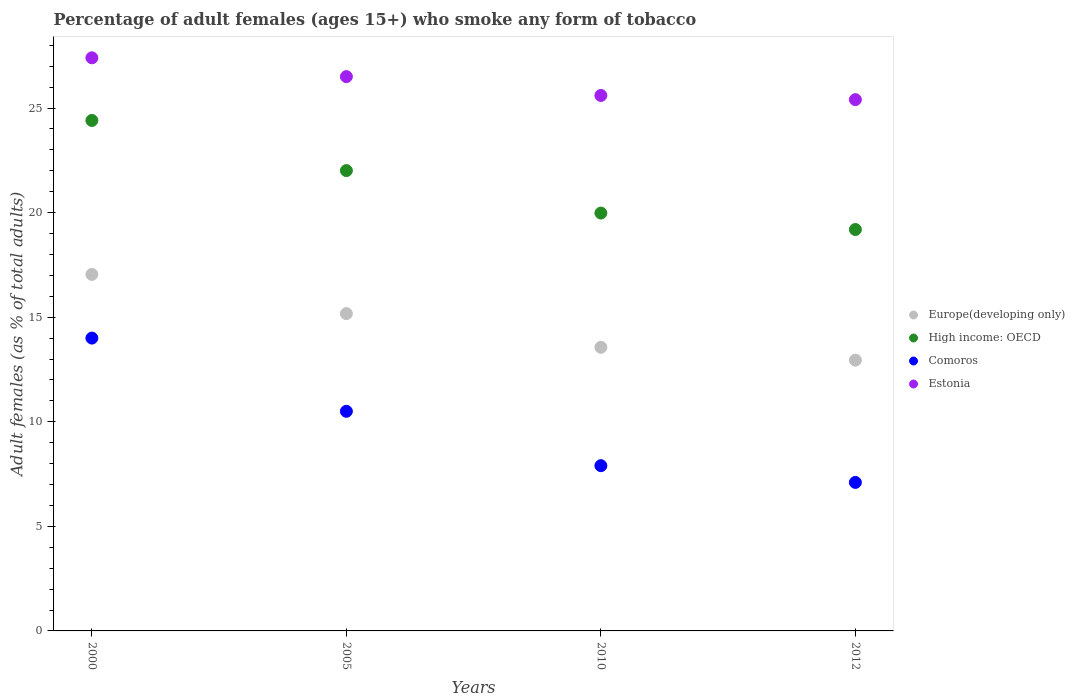Is the number of dotlines equal to the number of legend labels?
Offer a very short reply. Yes. What is the percentage of adult females who smoke in Europe(developing only) in 2000?
Give a very brief answer. 17.04. Across all years, what is the maximum percentage of adult females who smoke in Europe(developing only)?
Keep it short and to the point. 17.04. Across all years, what is the minimum percentage of adult females who smoke in Europe(developing only)?
Keep it short and to the point. 12.95. In which year was the percentage of adult females who smoke in High income: OECD minimum?
Ensure brevity in your answer.  2012. What is the total percentage of adult females who smoke in Estonia in the graph?
Keep it short and to the point. 104.9. What is the difference between the percentage of adult females who smoke in Estonia in 2005 and that in 2012?
Give a very brief answer. 1.1. What is the difference between the percentage of adult females who smoke in Europe(developing only) in 2012 and the percentage of adult females who smoke in High income: OECD in 2010?
Keep it short and to the point. -7.03. What is the average percentage of adult females who smoke in Estonia per year?
Make the answer very short. 26.23. In the year 2005, what is the difference between the percentage of adult females who smoke in High income: OECD and percentage of adult females who smoke in Comoros?
Offer a terse response. 11.51. In how many years, is the percentage of adult females who smoke in Estonia greater than 8 %?
Your response must be concise. 4. What is the ratio of the percentage of adult females who smoke in Europe(developing only) in 2000 to that in 2012?
Provide a short and direct response. 1.32. What is the difference between the highest and the second highest percentage of adult females who smoke in Comoros?
Offer a terse response. 3.5. What is the difference between the highest and the lowest percentage of adult females who smoke in Europe(developing only)?
Provide a succinct answer. 4.1. In how many years, is the percentage of adult females who smoke in High income: OECD greater than the average percentage of adult females who smoke in High income: OECD taken over all years?
Provide a short and direct response. 2. Is the sum of the percentage of adult females who smoke in Comoros in 2005 and 2012 greater than the maximum percentage of adult females who smoke in High income: OECD across all years?
Provide a short and direct response. No. Does the percentage of adult females who smoke in Estonia monotonically increase over the years?
Ensure brevity in your answer.  No. Is the percentage of adult females who smoke in Comoros strictly less than the percentage of adult females who smoke in Estonia over the years?
Make the answer very short. Yes. How many dotlines are there?
Keep it short and to the point. 4. How many years are there in the graph?
Make the answer very short. 4. What is the difference between two consecutive major ticks on the Y-axis?
Keep it short and to the point. 5. Does the graph contain grids?
Offer a very short reply. No. Where does the legend appear in the graph?
Offer a terse response. Center right. How many legend labels are there?
Ensure brevity in your answer.  4. How are the legend labels stacked?
Ensure brevity in your answer.  Vertical. What is the title of the graph?
Make the answer very short. Percentage of adult females (ages 15+) who smoke any form of tobacco. Does "High income: nonOECD" appear as one of the legend labels in the graph?
Make the answer very short. No. What is the label or title of the Y-axis?
Offer a very short reply. Adult females (as % of total adults). What is the Adult females (as % of total adults) in Europe(developing only) in 2000?
Offer a terse response. 17.04. What is the Adult females (as % of total adults) in High income: OECD in 2000?
Provide a short and direct response. 24.4. What is the Adult females (as % of total adults) in Comoros in 2000?
Offer a terse response. 14. What is the Adult females (as % of total adults) of Estonia in 2000?
Provide a succinct answer. 27.4. What is the Adult females (as % of total adults) in Europe(developing only) in 2005?
Offer a terse response. 15.17. What is the Adult females (as % of total adults) of High income: OECD in 2005?
Offer a terse response. 22.01. What is the Adult females (as % of total adults) in Europe(developing only) in 2010?
Keep it short and to the point. 13.56. What is the Adult females (as % of total adults) of High income: OECD in 2010?
Your response must be concise. 19.98. What is the Adult females (as % of total adults) of Estonia in 2010?
Provide a short and direct response. 25.6. What is the Adult females (as % of total adults) in Europe(developing only) in 2012?
Keep it short and to the point. 12.95. What is the Adult females (as % of total adults) of High income: OECD in 2012?
Give a very brief answer. 19.19. What is the Adult females (as % of total adults) of Estonia in 2012?
Give a very brief answer. 25.4. Across all years, what is the maximum Adult females (as % of total adults) of Europe(developing only)?
Provide a succinct answer. 17.04. Across all years, what is the maximum Adult females (as % of total adults) of High income: OECD?
Keep it short and to the point. 24.4. Across all years, what is the maximum Adult females (as % of total adults) in Comoros?
Offer a very short reply. 14. Across all years, what is the maximum Adult females (as % of total adults) in Estonia?
Provide a succinct answer. 27.4. Across all years, what is the minimum Adult females (as % of total adults) in Europe(developing only)?
Make the answer very short. 12.95. Across all years, what is the minimum Adult females (as % of total adults) of High income: OECD?
Provide a short and direct response. 19.19. Across all years, what is the minimum Adult females (as % of total adults) of Estonia?
Your response must be concise. 25.4. What is the total Adult females (as % of total adults) of Europe(developing only) in the graph?
Offer a very short reply. 58.72. What is the total Adult females (as % of total adults) of High income: OECD in the graph?
Offer a terse response. 85.58. What is the total Adult females (as % of total adults) in Comoros in the graph?
Ensure brevity in your answer.  39.5. What is the total Adult females (as % of total adults) of Estonia in the graph?
Provide a short and direct response. 104.9. What is the difference between the Adult females (as % of total adults) of Europe(developing only) in 2000 and that in 2005?
Your response must be concise. 1.87. What is the difference between the Adult females (as % of total adults) of High income: OECD in 2000 and that in 2005?
Give a very brief answer. 2.4. What is the difference between the Adult females (as % of total adults) in Europe(developing only) in 2000 and that in 2010?
Provide a succinct answer. 3.48. What is the difference between the Adult females (as % of total adults) of High income: OECD in 2000 and that in 2010?
Give a very brief answer. 4.43. What is the difference between the Adult females (as % of total adults) in Europe(developing only) in 2000 and that in 2012?
Keep it short and to the point. 4.1. What is the difference between the Adult females (as % of total adults) in High income: OECD in 2000 and that in 2012?
Make the answer very short. 5.21. What is the difference between the Adult females (as % of total adults) in Comoros in 2000 and that in 2012?
Your answer should be very brief. 6.9. What is the difference between the Adult females (as % of total adults) in Europe(developing only) in 2005 and that in 2010?
Give a very brief answer. 1.61. What is the difference between the Adult females (as % of total adults) in High income: OECD in 2005 and that in 2010?
Provide a succinct answer. 2.03. What is the difference between the Adult females (as % of total adults) of Comoros in 2005 and that in 2010?
Your response must be concise. 2.6. What is the difference between the Adult females (as % of total adults) in Estonia in 2005 and that in 2010?
Your answer should be very brief. 0.9. What is the difference between the Adult females (as % of total adults) in Europe(developing only) in 2005 and that in 2012?
Ensure brevity in your answer.  2.22. What is the difference between the Adult females (as % of total adults) of High income: OECD in 2005 and that in 2012?
Give a very brief answer. 2.82. What is the difference between the Adult females (as % of total adults) of Europe(developing only) in 2010 and that in 2012?
Provide a succinct answer. 0.61. What is the difference between the Adult females (as % of total adults) of High income: OECD in 2010 and that in 2012?
Ensure brevity in your answer.  0.79. What is the difference between the Adult females (as % of total adults) of Comoros in 2010 and that in 2012?
Offer a very short reply. 0.8. What is the difference between the Adult females (as % of total adults) of Europe(developing only) in 2000 and the Adult females (as % of total adults) of High income: OECD in 2005?
Your response must be concise. -4.96. What is the difference between the Adult females (as % of total adults) in Europe(developing only) in 2000 and the Adult females (as % of total adults) in Comoros in 2005?
Give a very brief answer. 6.54. What is the difference between the Adult females (as % of total adults) in Europe(developing only) in 2000 and the Adult females (as % of total adults) in Estonia in 2005?
Your answer should be compact. -9.46. What is the difference between the Adult females (as % of total adults) of High income: OECD in 2000 and the Adult females (as % of total adults) of Comoros in 2005?
Ensure brevity in your answer.  13.9. What is the difference between the Adult females (as % of total adults) of High income: OECD in 2000 and the Adult females (as % of total adults) of Estonia in 2005?
Offer a terse response. -2.1. What is the difference between the Adult females (as % of total adults) of Comoros in 2000 and the Adult females (as % of total adults) of Estonia in 2005?
Offer a very short reply. -12.5. What is the difference between the Adult females (as % of total adults) in Europe(developing only) in 2000 and the Adult females (as % of total adults) in High income: OECD in 2010?
Keep it short and to the point. -2.93. What is the difference between the Adult females (as % of total adults) of Europe(developing only) in 2000 and the Adult females (as % of total adults) of Comoros in 2010?
Your response must be concise. 9.14. What is the difference between the Adult females (as % of total adults) in Europe(developing only) in 2000 and the Adult females (as % of total adults) in Estonia in 2010?
Offer a very short reply. -8.56. What is the difference between the Adult females (as % of total adults) in High income: OECD in 2000 and the Adult females (as % of total adults) in Comoros in 2010?
Your answer should be compact. 16.5. What is the difference between the Adult females (as % of total adults) in High income: OECD in 2000 and the Adult females (as % of total adults) in Estonia in 2010?
Ensure brevity in your answer.  -1.2. What is the difference between the Adult females (as % of total adults) in Comoros in 2000 and the Adult females (as % of total adults) in Estonia in 2010?
Keep it short and to the point. -11.6. What is the difference between the Adult females (as % of total adults) of Europe(developing only) in 2000 and the Adult females (as % of total adults) of High income: OECD in 2012?
Provide a succinct answer. -2.15. What is the difference between the Adult females (as % of total adults) of Europe(developing only) in 2000 and the Adult females (as % of total adults) of Comoros in 2012?
Make the answer very short. 9.94. What is the difference between the Adult females (as % of total adults) in Europe(developing only) in 2000 and the Adult females (as % of total adults) in Estonia in 2012?
Offer a very short reply. -8.36. What is the difference between the Adult females (as % of total adults) in High income: OECD in 2000 and the Adult females (as % of total adults) in Comoros in 2012?
Provide a succinct answer. 17.3. What is the difference between the Adult females (as % of total adults) of High income: OECD in 2000 and the Adult females (as % of total adults) of Estonia in 2012?
Offer a terse response. -1. What is the difference between the Adult females (as % of total adults) of Europe(developing only) in 2005 and the Adult females (as % of total adults) of High income: OECD in 2010?
Provide a succinct answer. -4.81. What is the difference between the Adult females (as % of total adults) in Europe(developing only) in 2005 and the Adult females (as % of total adults) in Comoros in 2010?
Offer a very short reply. 7.27. What is the difference between the Adult females (as % of total adults) in Europe(developing only) in 2005 and the Adult females (as % of total adults) in Estonia in 2010?
Provide a succinct answer. -10.43. What is the difference between the Adult females (as % of total adults) in High income: OECD in 2005 and the Adult females (as % of total adults) in Comoros in 2010?
Offer a terse response. 14.11. What is the difference between the Adult females (as % of total adults) in High income: OECD in 2005 and the Adult females (as % of total adults) in Estonia in 2010?
Your answer should be very brief. -3.59. What is the difference between the Adult females (as % of total adults) in Comoros in 2005 and the Adult females (as % of total adults) in Estonia in 2010?
Provide a short and direct response. -15.1. What is the difference between the Adult females (as % of total adults) of Europe(developing only) in 2005 and the Adult females (as % of total adults) of High income: OECD in 2012?
Offer a terse response. -4.02. What is the difference between the Adult females (as % of total adults) in Europe(developing only) in 2005 and the Adult females (as % of total adults) in Comoros in 2012?
Keep it short and to the point. 8.07. What is the difference between the Adult females (as % of total adults) in Europe(developing only) in 2005 and the Adult females (as % of total adults) in Estonia in 2012?
Your response must be concise. -10.23. What is the difference between the Adult females (as % of total adults) in High income: OECD in 2005 and the Adult females (as % of total adults) in Comoros in 2012?
Your answer should be very brief. 14.91. What is the difference between the Adult females (as % of total adults) in High income: OECD in 2005 and the Adult females (as % of total adults) in Estonia in 2012?
Provide a succinct answer. -3.39. What is the difference between the Adult females (as % of total adults) of Comoros in 2005 and the Adult females (as % of total adults) of Estonia in 2012?
Ensure brevity in your answer.  -14.9. What is the difference between the Adult females (as % of total adults) in Europe(developing only) in 2010 and the Adult females (as % of total adults) in High income: OECD in 2012?
Ensure brevity in your answer.  -5.63. What is the difference between the Adult females (as % of total adults) in Europe(developing only) in 2010 and the Adult females (as % of total adults) in Comoros in 2012?
Provide a short and direct response. 6.46. What is the difference between the Adult females (as % of total adults) of Europe(developing only) in 2010 and the Adult females (as % of total adults) of Estonia in 2012?
Ensure brevity in your answer.  -11.84. What is the difference between the Adult females (as % of total adults) of High income: OECD in 2010 and the Adult females (as % of total adults) of Comoros in 2012?
Give a very brief answer. 12.88. What is the difference between the Adult females (as % of total adults) of High income: OECD in 2010 and the Adult females (as % of total adults) of Estonia in 2012?
Keep it short and to the point. -5.42. What is the difference between the Adult females (as % of total adults) of Comoros in 2010 and the Adult females (as % of total adults) of Estonia in 2012?
Make the answer very short. -17.5. What is the average Adult females (as % of total adults) in Europe(developing only) per year?
Keep it short and to the point. 14.68. What is the average Adult females (as % of total adults) of High income: OECD per year?
Your answer should be compact. 21.4. What is the average Adult females (as % of total adults) in Comoros per year?
Your answer should be compact. 9.88. What is the average Adult females (as % of total adults) of Estonia per year?
Make the answer very short. 26.23. In the year 2000, what is the difference between the Adult females (as % of total adults) of Europe(developing only) and Adult females (as % of total adults) of High income: OECD?
Provide a succinct answer. -7.36. In the year 2000, what is the difference between the Adult females (as % of total adults) in Europe(developing only) and Adult females (as % of total adults) in Comoros?
Your answer should be very brief. 3.04. In the year 2000, what is the difference between the Adult females (as % of total adults) in Europe(developing only) and Adult females (as % of total adults) in Estonia?
Keep it short and to the point. -10.36. In the year 2000, what is the difference between the Adult females (as % of total adults) of High income: OECD and Adult females (as % of total adults) of Comoros?
Your answer should be compact. 10.4. In the year 2000, what is the difference between the Adult females (as % of total adults) in High income: OECD and Adult females (as % of total adults) in Estonia?
Your answer should be compact. -3. In the year 2000, what is the difference between the Adult females (as % of total adults) in Comoros and Adult females (as % of total adults) in Estonia?
Offer a terse response. -13.4. In the year 2005, what is the difference between the Adult females (as % of total adults) in Europe(developing only) and Adult females (as % of total adults) in High income: OECD?
Provide a short and direct response. -6.84. In the year 2005, what is the difference between the Adult females (as % of total adults) of Europe(developing only) and Adult females (as % of total adults) of Comoros?
Ensure brevity in your answer.  4.67. In the year 2005, what is the difference between the Adult females (as % of total adults) of Europe(developing only) and Adult females (as % of total adults) of Estonia?
Keep it short and to the point. -11.33. In the year 2005, what is the difference between the Adult females (as % of total adults) in High income: OECD and Adult females (as % of total adults) in Comoros?
Offer a very short reply. 11.51. In the year 2005, what is the difference between the Adult females (as % of total adults) in High income: OECD and Adult females (as % of total adults) in Estonia?
Provide a succinct answer. -4.49. In the year 2005, what is the difference between the Adult females (as % of total adults) in Comoros and Adult females (as % of total adults) in Estonia?
Your answer should be compact. -16. In the year 2010, what is the difference between the Adult females (as % of total adults) in Europe(developing only) and Adult females (as % of total adults) in High income: OECD?
Your answer should be compact. -6.42. In the year 2010, what is the difference between the Adult females (as % of total adults) in Europe(developing only) and Adult females (as % of total adults) in Comoros?
Your answer should be very brief. 5.66. In the year 2010, what is the difference between the Adult females (as % of total adults) in Europe(developing only) and Adult females (as % of total adults) in Estonia?
Provide a succinct answer. -12.04. In the year 2010, what is the difference between the Adult females (as % of total adults) of High income: OECD and Adult females (as % of total adults) of Comoros?
Keep it short and to the point. 12.08. In the year 2010, what is the difference between the Adult females (as % of total adults) of High income: OECD and Adult females (as % of total adults) of Estonia?
Keep it short and to the point. -5.62. In the year 2010, what is the difference between the Adult females (as % of total adults) in Comoros and Adult females (as % of total adults) in Estonia?
Offer a terse response. -17.7. In the year 2012, what is the difference between the Adult females (as % of total adults) of Europe(developing only) and Adult females (as % of total adults) of High income: OECD?
Your answer should be compact. -6.25. In the year 2012, what is the difference between the Adult females (as % of total adults) of Europe(developing only) and Adult females (as % of total adults) of Comoros?
Offer a very short reply. 5.85. In the year 2012, what is the difference between the Adult females (as % of total adults) in Europe(developing only) and Adult females (as % of total adults) in Estonia?
Give a very brief answer. -12.45. In the year 2012, what is the difference between the Adult females (as % of total adults) of High income: OECD and Adult females (as % of total adults) of Comoros?
Ensure brevity in your answer.  12.09. In the year 2012, what is the difference between the Adult females (as % of total adults) in High income: OECD and Adult females (as % of total adults) in Estonia?
Provide a short and direct response. -6.21. In the year 2012, what is the difference between the Adult females (as % of total adults) in Comoros and Adult females (as % of total adults) in Estonia?
Provide a succinct answer. -18.3. What is the ratio of the Adult females (as % of total adults) in Europe(developing only) in 2000 to that in 2005?
Make the answer very short. 1.12. What is the ratio of the Adult females (as % of total adults) of High income: OECD in 2000 to that in 2005?
Your response must be concise. 1.11. What is the ratio of the Adult females (as % of total adults) in Estonia in 2000 to that in 2005?
Your answer should be very brief. 1.03. What is the ratio of the Adult females (as % of total adults) of Europe(developing only) in 2000 to that in 2010?
Your answer should be compact. 1.26. What is the ratio of the Adult females (as % of total adults) in High income: OECD in 2000 to that in 2010?
Give a very brief answer. 1.22. What is the ratio of the Adult females (as % of total adults) in Comoros in 2000 to that in 2010?
Offer a terse response. 1.77. What is the ratio of the Adult females (as % of total adults) of Estonia in 2000 to that in 2010?
Offer a very short reply. 1.07. What is the ratio of the Adult females (as % of total adults) of Europe(developing only) in 2000 to that in 2012?
Provide a short and direct response. 1.32. What is the ratio of the Adult females (as % of total adults) in High income: OECD in 2000 to that in 2012?
Your response must be concise. 1.27. What is the ratio of the Adult females (as % of total adults) of Comoros in 2000 to that in 2012?
Provide a short and direct response. 1.97. What is the ratio of the Adult females (as % of total adults) in Estonia in 2000 to that in 2012?
Your response must be concise. 1.08. What is the ratio of the Adult females (as % of total adults) in Europe(developing only) in 2005 to that in 2010?
Your answer should be very brief. 1.12. What is the ratio of the Adult females (as % of total adults) in High income: OECD in 2005 to that in 2010?
Give a very brief answer. 1.1. What is the ratio of the Adult females (as % of total adults) in Comoros in 2005 to that in 2010?
Your answer should be compact. 1.33. What is the ratio of the Adult females (as % of total adults) in Estonia in 2005 to that in 2010?
Provide a short and direct response. 1.04. What is the ratio of the Adult females (as % of total adults) in Europe(developing only) in 2005 to that in 2012?
Provide a succinct answer. 1.17. What is the ratio of the Adult females (as % of total adults) in High income: OECD in 2005 to that in 2012?
Provide a short and direct response. 1.15. What is the ratio of the Adult females (as % of total adults) in Comoros in 2005 to that in 2012?
Make the answer very short. 1.48. What is the ratio of the Adult females (as % of total adults) of Estonia in 2005 to that in 2012?
Offer a terse response. 1.04. What is the ratio of the Adult females (as % of total adults) in Europe(developing only) in 2010 to that in 2012?
Make the answer very short. 1.05. What is the ratio of the Adult females (as % of total adults) of High income: OECD in 2010 to that in 2012?
Provide a succinct answer. 1.04. What is the ratio of the Adult females (as % of total adults) in Comoros in 2010 to that in 2012?
Ensure brevity in your answer.  1.11. What is the ratio of the Adult females (as % of total adults) in Estonia in 2010 to that in 2012?
Make the answer very short. 1.01. What is the difference between the highest and the second highest Adult females (as % of total adults) in Europe(developing only)?
Your answer should be very brief. 1.87. What is the difference between the highest and the second highest Adult females (as % of total adults) in High income: OECD?
Offer a terse response. 2.4. What is the difference between the highest and the second highest Adult females (as % of total adults) of Comoros?
Your response must be concise. 3.5. What is the difference between the highest and the lowest Adult females (as % of total adults) of Europe(developing only)?
Offer a very short reply. 4.1. What is the difference between the highest and the lowest Adult females (as % of total adults) in High income: OECD?
Provide a succinct answer. 5.21. What is the difference between the highest and the lowest Adult females (as % of total adults) of Estonia?
Make the answer very short. 2. 